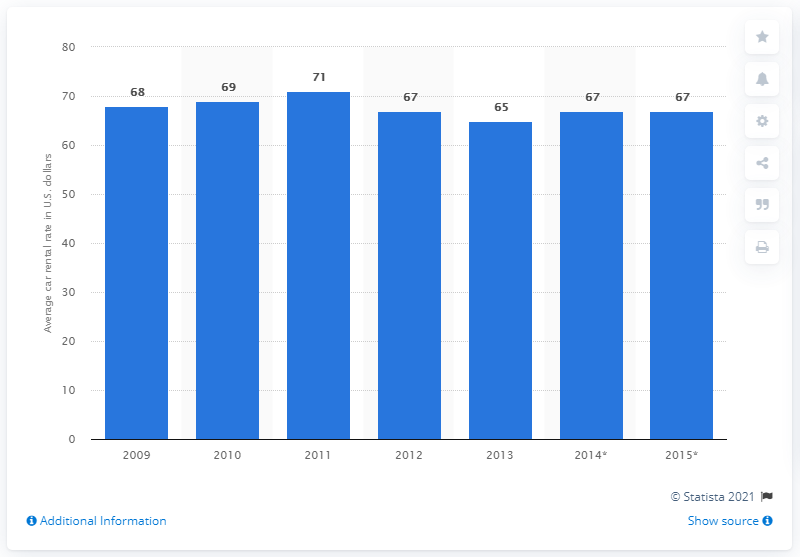Draw attention to some important aspects in this diagram. In 2013, the average global car rental rate was approximately 65%. The global car rental rate forecast was expected to increase by 67% in 2014. 